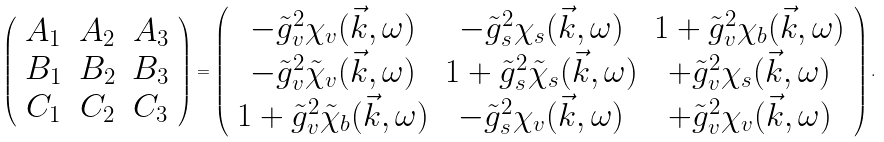Convert formula to latex. <formula><loc_0><loc_0><loc_500><loc_500>\left ( \begin{array} { c c c } A _ { 1 } & A _ { 2 } & A _ { 3 } \\ B _ { 1 } & B _ { 2 } & B _ { 3 } \\ C _ { 1 } & C _ { 2 } & C _ { 3 } \\ \end{array} \right ) = \left ( \begin{array} { c c c } - \tilde { g } _ { v } ^ { 2 } \chi _ { v } ( \vec { k } , \omega ) & - \tilde { g } _ { s } ^ { 2 } \chi _ { s } ( \vec { k } , \omega ) & 1 + \tilde { g } _ { v } ^ { 2 } \chi _ { b } ( \vec { k } , \omega ) \\ - \tilde { g } _ { v } ^ { 2 } \tilde { \chi } _ { v } ( \vec { k } , \omega ) & 1 + \tilde { g } _ { s } ^ { 2 } \tilde { \chi } _ { s } ( \vec { k } , \omega ) & + \tilde { g } _ { v } ^ { 2 } \chi _ { s } ( \vec { k } , \omega ) \\ 1 + \tilde { g } _ { v } ^ { 2 } \tilde { \chi } _ { b } ( \vec { k } , \omega ) & - \tilde { g } _ { s } ^ { 2 } \chi _ { v } ( \vec { k } , \omega ) & + \tilde { g } _ { v } ^ { 2 } \chi _ { v } ( \vec { k } , \omega ) \\ \end{array} \right ) .</formula> 